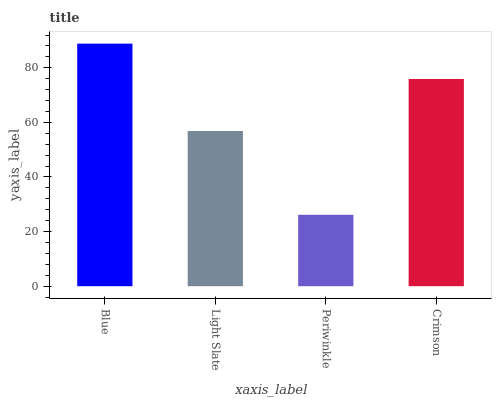Is Periwinkle the minimum?
Answer yes or no. Yes. Is Blue the maximum?
Answer yes or no. Yes. Is Light Slate the minimum?
Answer yes or no. No. Is Light Slate the maximum?
Answer yes or no. No. Is Blue greater than Light Slate?
Answer yes or no. Yes. Is Light Slate less than Blue?
Answer yes or no. Yes. Is Light Slate greater than Blue?
Answer yes or no. No. Is Blue less than Light Slate?
Answer yes or no. No. Is Crimson the high median?
Answer yes or no. Yes. Is Light Slate the low median?
Answer yes or no. Yes. Is Periwinkle the high median?
Answer yes or no. No. Is Blue the low median?
Answer yes or no. No. 